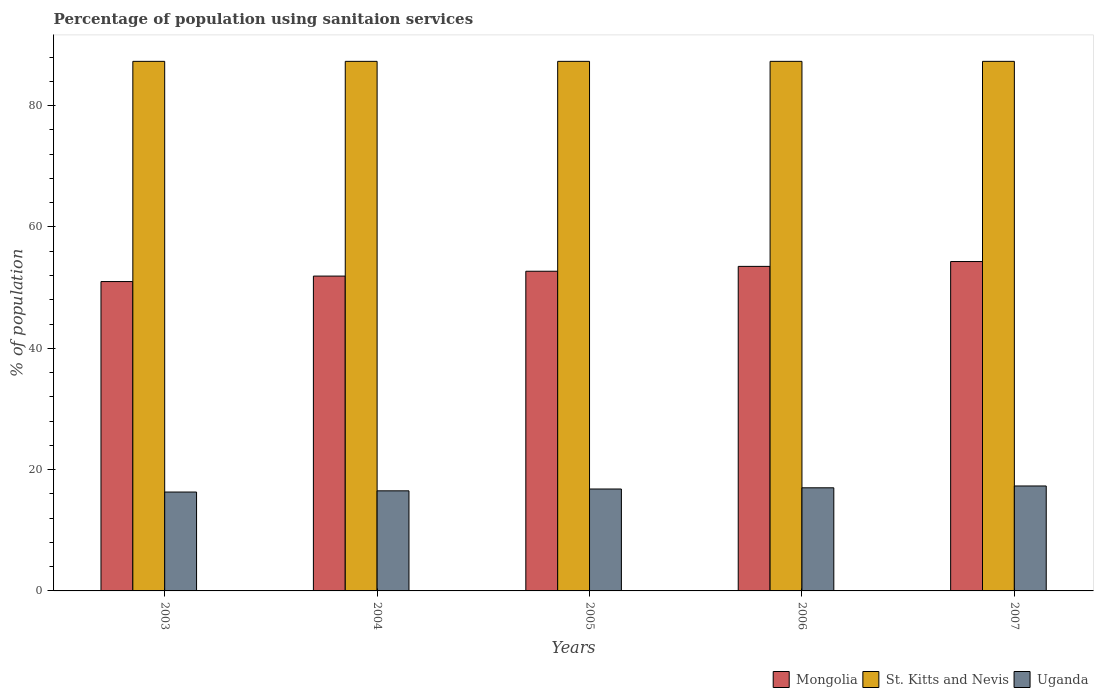How many groups of bars are there?
Provide a short and direct response. 5. Are the number of bars per tick equal to the number of legend labels?
Your answer should be compact. Yes. How many bars are there on the 3rd tick from the left?
Your answer should be compact. 3. What is the label of the 1st group of bars from the left?
Provide a succinct answer. 2003. What is the percentage of population using sanitaion services in Uganda in 2004?
Give a very brief answer. 16.5. Across all years, what is the maximum percentage of population using sanitaion services in St. Kitts and Nevis?
Offer a very short reply. 87.3. Across all years, what is the minimum percentage of population using sanitaion services in Mongolia?
Your answer should be very brief. 51. In which year was the percentage of population using sanitaion services in St. Kitts and Nevis maximum?
Your answer should be compact. 2003. In which year was the percentage of population using sanitaion services in Mongolia minimum?
Provide a succinct answer. 2003. What is the total percentage of population using sanitaion services in Mongolia in the graph?
Ensure brevity in your answer.  263.4. What is the difference between the percentage of population using sanitaion services in Mongolia in 2006 and that in 2007?
Provide a succinct answer. -0.8. What is the difference between the percentage of population using sanitaion services in Mongolia in 2003 and the percentage of population using sanitaion services in St. Kitts and Nevis in 2006?
Your answer should be very brief. -36.3. What is the average percentage of population using sanitaion services in St. Kitts and Nevis per year?
Make the answer very short. 87.3. In the year 2005, what is the difference between the percentage of population using sanitaion services in Mongolia and percentage of population using sanitaion services in Uganda?
Your answer should be compact. 35.9. In how many years, is the percentage of population using sanitaion services in St. Kitts and Nevis greater than 8 %?
Give a very brief answer. 5. What is the ratio of the percentage of population using sanitaion services in Mongolia in 2004 to that in 2006?
Provide a short and direct response. 0.97. Is the difference between the percentage of population using sanitaion services in Mongolia in 2006 and 2007 greater than the difference between the percentage of population using sanitaion services in Uganda in 2006 and 2007?
Provide a succinct answer. No. What is the difference between the highest and the second highest percentage of population using sanitaion services in Uganda?
Make the answer very short. 0.3. What does the 3rd bar from the left in 2003 represents?
Offer a terse response. Uganda. What does the 3rd bar from the right in 2007 represents?
Your response must be concise. Mongolia. How many bars are there?
Ensure brevity in your answer.  15. Are all the bars in the graph horizontal?
Provide a short and direct response. No. How many years are there in the graph?
Give a very brief answer. 5. What is the difference between two consecutive major ticks on the Y-axis?
Provide a succinct answer. 20. Are the values on the major ticks of Y-axis written in scientific E-notation?
Provide a short and direct response. No. Does the graph contain any zero values?
Keep it short and to the point. No. How many legend labels are there?
Provide a short and direct response. 3. How are the legend labels stacked?
Offer a very short reply. Horizontal. What is the title of the graph?
Provide a short and direct response. Percentage of population using sanitaion services. Does "Turkmenistan" appear as one of the legend labels in the graph?
Your answer should be very brief. No. What is the label or title of the X-axis?
Your response must be concise. Years. What is the label or title of the Y-axis?
Give a very brief answer. % of population. What is the % of population of St. Kitts and Nevis in 2003?
Ensure brevity in your answer.  87.3. What is the % of population in Mongolia in 2004?
Keep it short and to the point. 51.9. What is the % of population in St. Kitts and Nevis in 2004?
Make the answer very short. 87.3. What is the % of population in Uganda in 2004?
Provide a short and direct response. 16.5. What is the % of population of Mongolia in 2005?
Offer a very short reply. 52.7. What is the % of population of St. Kitts and Nevis in 2005?
Your answer should be compact. 87.3. What is the % of population in Mongolia in 2006?
Offer a very short reply. 53.5. What is the % of population of St. Kitts and Nevis in 2006?
Offer a terse response. 87.3. What is the % of population of Mongolia in 2007?
Provide a succinct answer. 54.3. What is the % of population in St. Kitts and Nevis in 2007?
Ensure brevity in your answer.  87.3. What is the % of population in Uganda in 2007?
Provide a succinct answer. 17.3. Across all years, what is the maximum % of population of Mongolia?
Give a very brief answer. 54.3. Across all years, what is the maximum % of population of St. Kitts and Nevis?
Your response must be concise. 87.3. Across all years, what is the minimum % of population of Mongolia?
Make the answer very short. 51. Across all years, what is the minimum % of population of St. Kitts and Nevis?
Your answer should be compact. 87.3. Across all years, what is the minimum % of population of Uganda?
Your response must be concise. 16.3. What is the total % of population of Mongolia in the graph?
Your response must be concise. 263.4. What is the total % of population of St. Kitts and Nevis in the graph?
Provide a short and direct response. 436.5. What is the total % of population of Uganda in the graph?
Your response must be concise. 83.9. What is the difference between the % of population of St. Kitts and Nevis in 2003 and that in 2004?
Ensure brevity in your answer.  0. What is the difference between the % of population of Mongolia in 2003 and that in 2005?
Make the answer very short. -1.7. What is the difference between the % of population in St. Kitts and Nevis in 2003 and that in 2006?
Provide a succinct answer. 0. What is the difference between the % of population of Uganda in 2003 and that in 2006?
Make the answer very short. -0.7. What is the difference between the % of population in St. Kitts and Nevis in 2003 and that in 2007?
Offer a terse response. 0. What is the difference between the % of population of Mongolia in 2004 and that in 2005?
Make the answer very short. -0.8. What is the difference between the % of population in St. Kitts and Nevis in 2004 and that in 2005?
Provide a succinct answer. 0. What is the difference between the % of population in St. Kitts and Nevis in 2004 and that in 2006?
Offer a terse response. 0. What is the difference between the % of population in Mongolia in 2004 and that in 2007?
Ensure brevity in your answer.  -2.4. What is the difference between the % of population in St. Kitts and Nevis in 2004 and that in 2007?
Provide a succinct answer. 0. What is the difference between the % of population in Uganda in 2004 and that in 2007?
Make the answer very short. -0.8. What is the difference between the % of population of St. Kitts and Nevis in 2005 and that in 2006?
Keep it short and to the point. 0. What is the difference between the % of population in Uganda in 2005 and that in 2006?
Provide a short and direct response. -0.2. What is the difference between the % of population of Mongolia in 2006 and that in 2007?
Offer a terse response. -0.8. What is the difference between the % of population of Mongolia in 2003 and the % of population of St. Kitts and Nevis in 2004?
Keep it short and to the point. -36.3. What is the difference between the % of population in Mongolia in 2003 and the % of population in Uganda in 2004?
Your answer should be compact. 34.5. What is the difference between the % of population in St. Kitts and Nevis in 2003 and the % of population in Uganda in 2004?
Your response must be concise. 70.8. What is the difference between the % of population of Mongolia in 2003 and the % of population of St. Kitts and Nevis in 2005?
Ensure brevity in your answer.  -36.3. What is the difference between the % of population of Mongolia in 2003 and the % of population of Uganda in 2005?
Your answer should be very brief. 34.2. What is the difference between the % of population of St. Kitts and Nevis in 2003 and the % of population of Uganda in 2005?
Keep it short and to the point. 70.5. What is the difference between the % of population in Mongolia in 2003 and the % of population in St. Kitts and Nevis in 2006?
Your answer should be very brief. -36.3. What is the difference between the % of population in Mongolia in 2003 and the % of population in Uganda in 2006?
Keep it short and to the point. 34. What is the difference between the % of population of St. Kitts and Nevis in 2003 and the % of population of Uganda in 2006?
Offer a very short reply. 70.3. What is the difference between the % of population in Mongolia in 2003 and the % of population in St. Kitts and Nevis in 2007?
Offer a terse response. -36.3. What is the difference between the % of population of Mongolia in 2003 and the % of population of Uganda in 2007?
Offer a very short reply. 33.7. What is the difference between the % of population in Mongolia in 2004 and the % of population in St. Kitts and Nevis in 2005?
Your answer should be compact. -35.4. What is the difference between the % of population of Mongolia in 2004 and the % of population of Uganda in 2005?
Provide a succinct answer. 35.1. What is the difference between the % of population of St. Kitts and Nevis in 2004 and the % of population of Uganda in 2005?
Your answer should be compact. 70.5. What is the difference between the % of population of Mongolia in 2004 and the % of population of St. Kitts and Nevis in 2006?
Your response must be concise. -35.4. What is the difference between the % of population in Mongolia in 2004 and the % of population in Uganda in 2006?
Provide a succinct answer. 34.9. What is the difference between the % of population of St. Kitts and Nevis in 2004 and the % of population of Uganda in 2006?
Your answer should be very brief. 70.3. What is the difference between the % of population of Mongolia in 2004 and the % of population of St. Kitts and Nevis in 2007?
Ensure brevity in your answer.  -35.4. What is the difference between the % of population of Mongolia in 2004 and the % of population of Uganda in 2007?
Your answer should be very brief. 34.6. What is the difference between the % of population in Mongolia in 2005 and the % of population in St. Kitts and Nevis in 2006?
Ensure brevity in your answer.  -34.6. What is the difference between the % of population of Mongolia in 2005 and the % of population of Uganda in 2006?
Make the answer very short. 35.7. What is the difference between the % of population of St. Kitts and Nevis in 2005 and the % of population of Uganda in 2006?
Give a very brief answer. 70.3. What is the difference between the % of population of Mongolia in 2005 and the % of population of St. Kitts and Nevis in 2007?
Offer a terse response. -34.6. What is the difference between the % of population in Mongolia in 2005 and the % of population in Uganda in 2007?
Provide a succinct answer. 35.4. What is the difference between the % of population in Mongolia in 2006 and the % of population in St. Kitts and Nevis in 2007?
Make the answer very short. -33.8. What is the difference between the % of population in Mongolia in 2006 and the % of population in Uganda in 2007?
Provide a short and direct response. 36.2. What is the average % of population of Mongolia per year?
Give a very brief answer. 52.68. What is the average % of population in St. Kitts and Nevis per year?
Your answer should be compact. 87.3. What is the average % of population of Uganda per year?
Provide a succinct answer. 16.78. In the year 2003, what is the difference between the % of population of Mongolia and % of population of St. Kitts and Nevis?
Provide a short and direct response. -36.3. In the year 2003, what is the difference between the % of population of Mongolia and % of population of Uganda?
Your answer should be very brief. 34.7. In the year 2003, what is the difference between the % of population of St. Kitts and Nevis and % of population of Uganda?
Provide a short and direct response. 71. In the year 2004, what is the difference between the % of population of Mongolia and % of population of St. Kitts and Nevis?
Offer a terse response. -35.4. In the year 2004, what is the difference between the % of population of Mongolia and % of population of Uganda?
Offer a terse response. 35.4. In the year 2004, what is the difference between the % of population of St. Kitts and Nevis and % of population of Uganda?
Ensure brevity in your answer.  70.8. In the year 2005, what is the difference between the % of population in Mongolia and % of population in St. Kitts and Nevis?
Your answer should be compact. -34.6. In the year 2005, what is the difference between the % of population in Mongolia and % of population in Uganda?
Your answer should be compact. 35.9. In the year 2005, what is the difference between the % of population in St. Kitts and Nevis and % of population in Uganda?
Provide a succinct answer. 70.5. In the year 2006, what is the difference between the % of population in Mongolia and % of population in St. Kitts and Nevis?
Give a very brief answer. -33.8. In the year 2006, what is the difference between the % of population of Mongolia and % of population of Uganda?
Keep it short and to the point. 36.5. In the year 2006, what is the difference between the % of population in St. Kitts and Nevis and % of population in Uganda?
Keep it short and to the point. 70.3. In the year 2007, what is the difference between the % of population of Mongolia and % of population of St. Kitts and Nevis?
Ensure brevity in your answer.  -33. In the year 2007, what is the difference between the % of population in Mongolia and % of population in Uganda?
Offer a terse response. 37. In the year 2007, what is the difference between the % of population in St. Kitts and Nevis and % of population in Uganda?
Make the answer very short. 70. What is the ratio of the % of population in Mongolia in 2003 to that in 2004?
Your answer should be compact. 0.98. What is the ratio of the % of population of St. Kitts and Nevis in 2003 to that in 2004?
Provide a short and direct response. 1. What is the ratio of the % of population in Uganda in 2003 to that in 2004?
Keep it short and to the point. 0.99. What is the ratio of the % of population of Mongolia in 2003 to that in 2005?
Ensure brevity in your answer.  0.97. What is the ratio of the % of population of Uganda in 2003 to that in 2005?
Keep it short and to the point. 0.97. What is the ratio of the % of population of Mongolia in 2003 to that in 2006?
Offer a very short reply. 0.95. What is the ratio of the % of population in St. Kitts and Nevis in 2003 to that in 2006?
Make the answer very short. 1. What is the ratio of the % of population in Uganda in 2003 to that in 2006?
Provide a short and direct response. 0.96. What is the ratio of the % of population in Mongolia in 2003 to that in 2007?
Provide a succinct answer. 0.94. What is the ratio of the % of population in St. Kitts and Nevis in 2003 to that in 2007?
Your response must be concise. 1. What is the ratio of the % of population in Uganda in 2003 to that in 2007?
Your response must be concise. 0.94. What is the ratio of the % of population of Mongolia in 2004 to that in 2005?
Provide a short and direct response. 0.98. What is the ratio of the % of population in Uganda in 2004 to that in 2005?
Your answer should be very brief. 0.98. What is the ratio of the % of population in Mongolia in 2004 to that in 2006?
Provide a short and direct response. 0.97. What is the ratio of the % of population of Uganda in 2004 to that in 2006?
Keep it short and to the point. 0.97. What is the ratio of the % of population of Mongolia in 2004 to that in 2007?
Keep it short and to the point. 0.96. What is the ratio of the % of population in St. Kitts and Nevis in 2004 to that in 2007?
Your response must be concise. 1. What is the ratio of the % of population in Uganda in 2004 to that in 2007?
Provide a short and direct response. 0.95. What is the ratio of the % of population in St. Kitts and Nevis in 2005 to that in 2006?
Offer a terse response. 1. What is the ratio of the % of population of Uganda in 2005 to that in 2006?
Keep it short and to the point. 0.99. What is the ratio of the % of population in Mongolia in 2005 to that in 2007?
Your answer should be very brief. 0.97. What is the ratio of the % of population in St. Kitts and Nevis in 2005 to that in 2007?
Your answer should be very brief. 1. What is the ratio of the % of population of Uganda in 2005 to that in 2007?
Provide a succinct answer. 0.97. What is the ratio of the % of population in Mongolia in 2006 to that in 2007?
Provide a succinct answer. 0.99. What is the ratio of the % of population in St. Kitts and Nevis in 2006 to that in 2007?
Provide a short and direct response. 1. What is the ratio of the % of population of Uganda in 2006 to that in 2007?
Your answer should be very brief. 0.98. What is the difference between the highest and the second highest % of population in Mongolia?
Make the answer very short. 0.8. What is the difference between the highest and the second highest % of population in St. Kitts and Nevis?
Offer a very short reply. 0. 